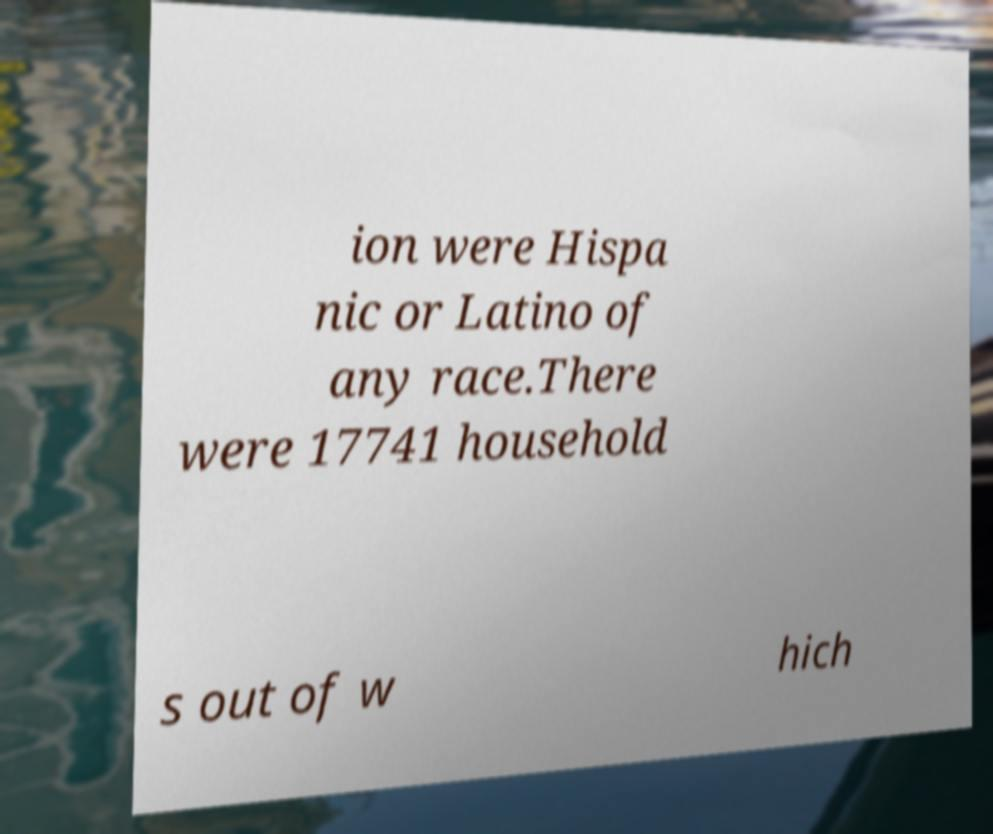Please identify and transcribe the text found in this image. ion were Hispa nic or Latino of any race.There were 17741 household s out of w hich 